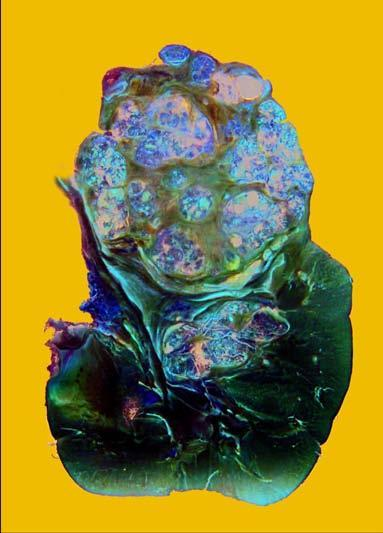what does the upper pole of the kidney show?
Answer the question using a single word or phrase. A large and tan mass 